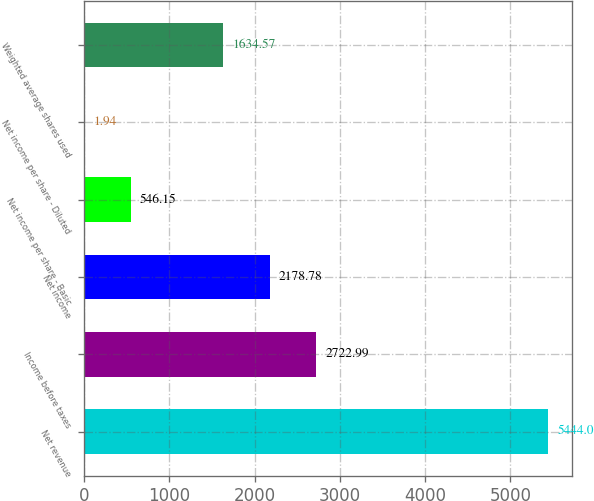Convert chart. <chart><loc_0><loc_0><loc_500><loc_500><bar_chart><fcel>Net revenue<fcel>Income before taxes<fcel>Net income<fcel>Net income per share - Basic<fcel>Net income per share - Diluted<fcel>Weighted average shares used<nl><fcel>5444<fcel>2722.99<fcel>2178.78<fcel>546.15<fcel>1.94<fcel>1634.57<nl></chart> 